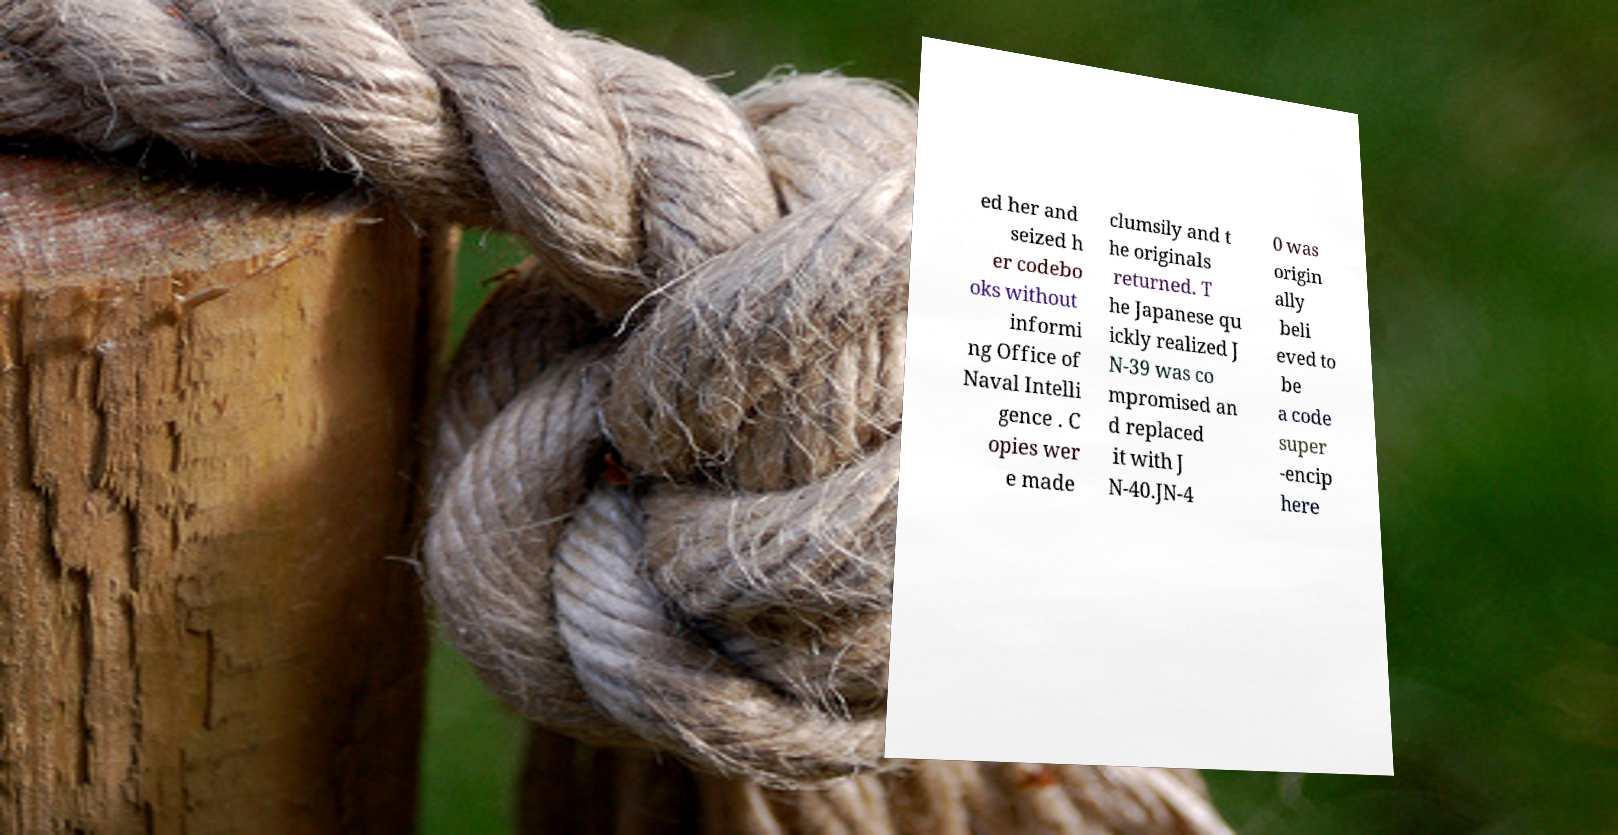Can you read and provide the text displayed in the image?This photo seems to have some interesting text. Can you extract and type it out for me? ed her and seized h er codebo oks without informi ng Office of Naval Intelli gence . C opies wer e made clumsily and t he originals returned. T he Japanese qu ickly realized J N-39 was co mpromised an d replaced it with J N-40.JN-4 0 was origin ally beli eved to be a code super -encip here 